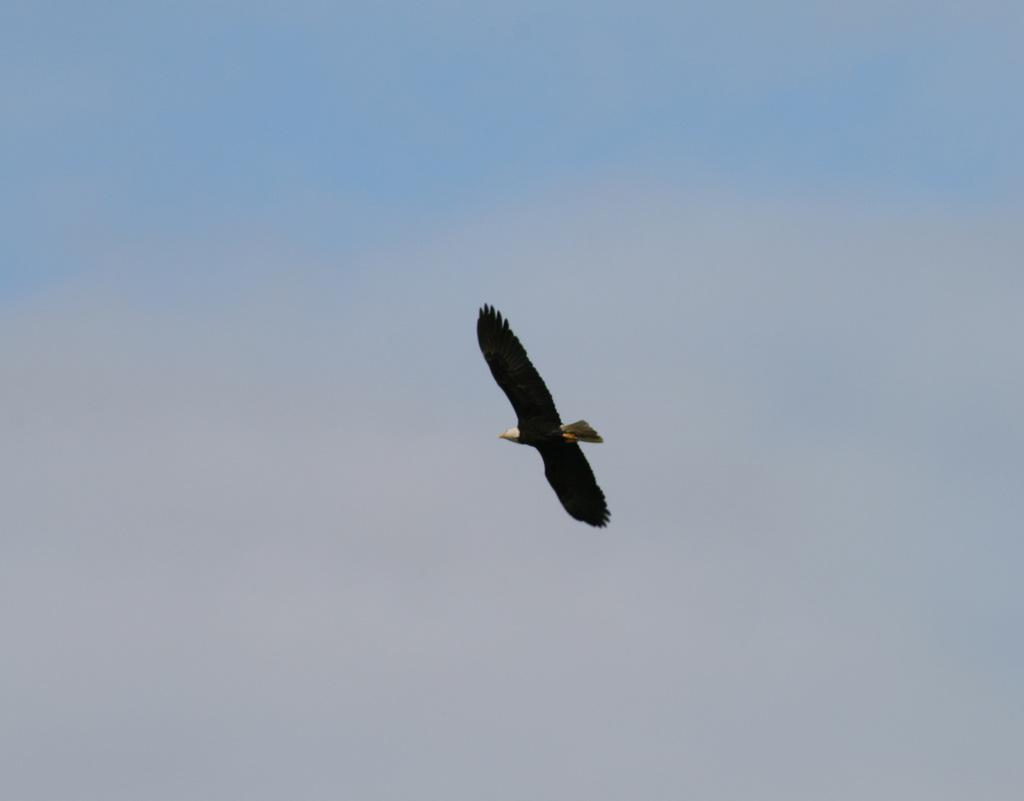What type of animal can be seen in the image? There is a bird in the image. What is the bird doing in the image? The bird is flying in the air. What is visible in the background of the image? The background of the image is the sky. What type of knowledge is the bird sharing with the lawyer in the image? There is no lawyer present in the image, and the bird is not sharing any knowledge. How many hands can be seen holding the bird in the image? There are no hands holding the bird in the image; the bird is flying freely. 